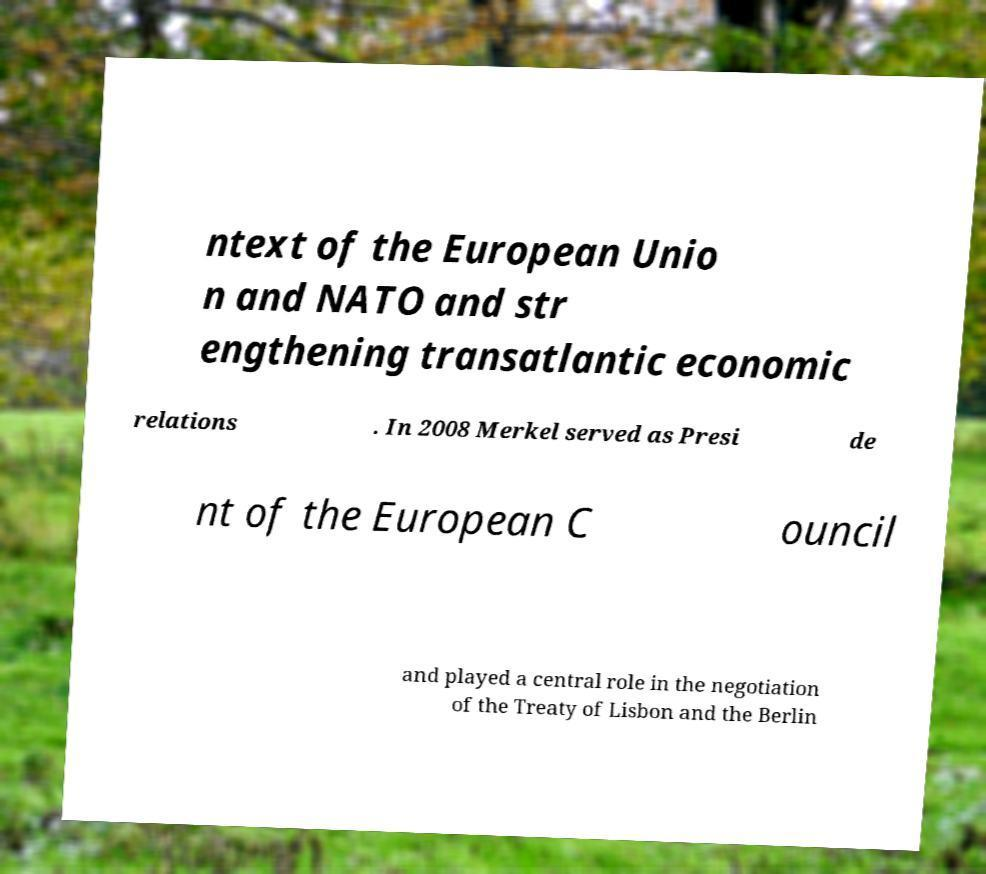Please identify and transcribe the text found in this image. ntext of the European Unio n and NATO and str engthening transatlantic economic relations . In 2008 Merkel served as Presi de nt of the European C ouncil and played a central role in the negotiation of the Treaty of Lisbon and the Berlin 